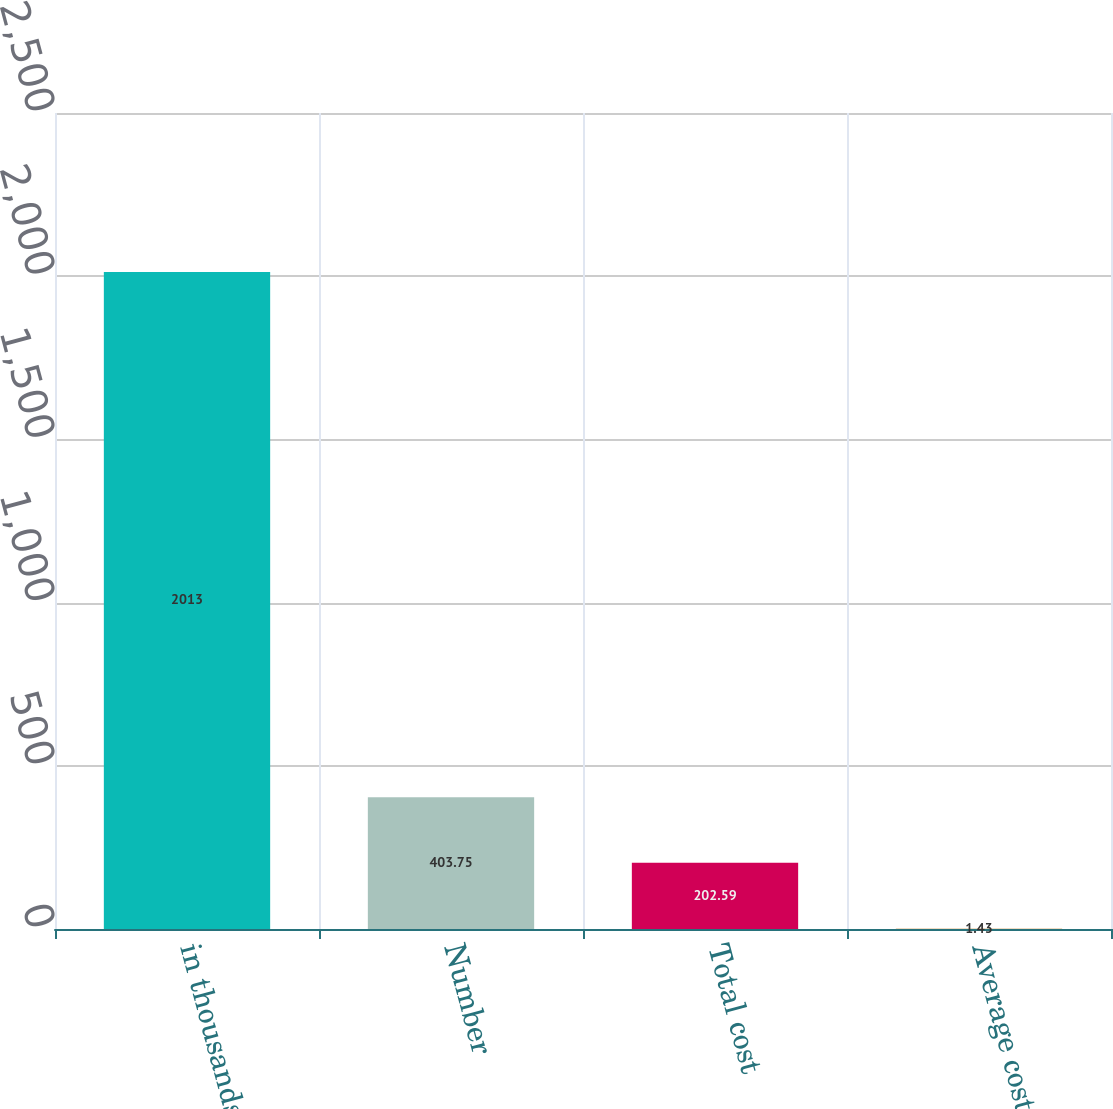<chart> <loc_0><loc_0><loc_500><loc_500><bar_chart><fcel>in thousands<fcel>Number<fcel>Total cost<fcel>Average cost<nl><fcel>2013<fcel>403.75<fcel>202.59<fcel>1.43<nl></chart> 